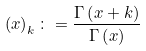<formula> <loc_0><loc_0><loc_500><loc_500>\left ( x \right ) _ { k } \colon = \frac { \Gamma \left ( x + k \right ) } { \Gamma \left ( x \right ) }</formula> 